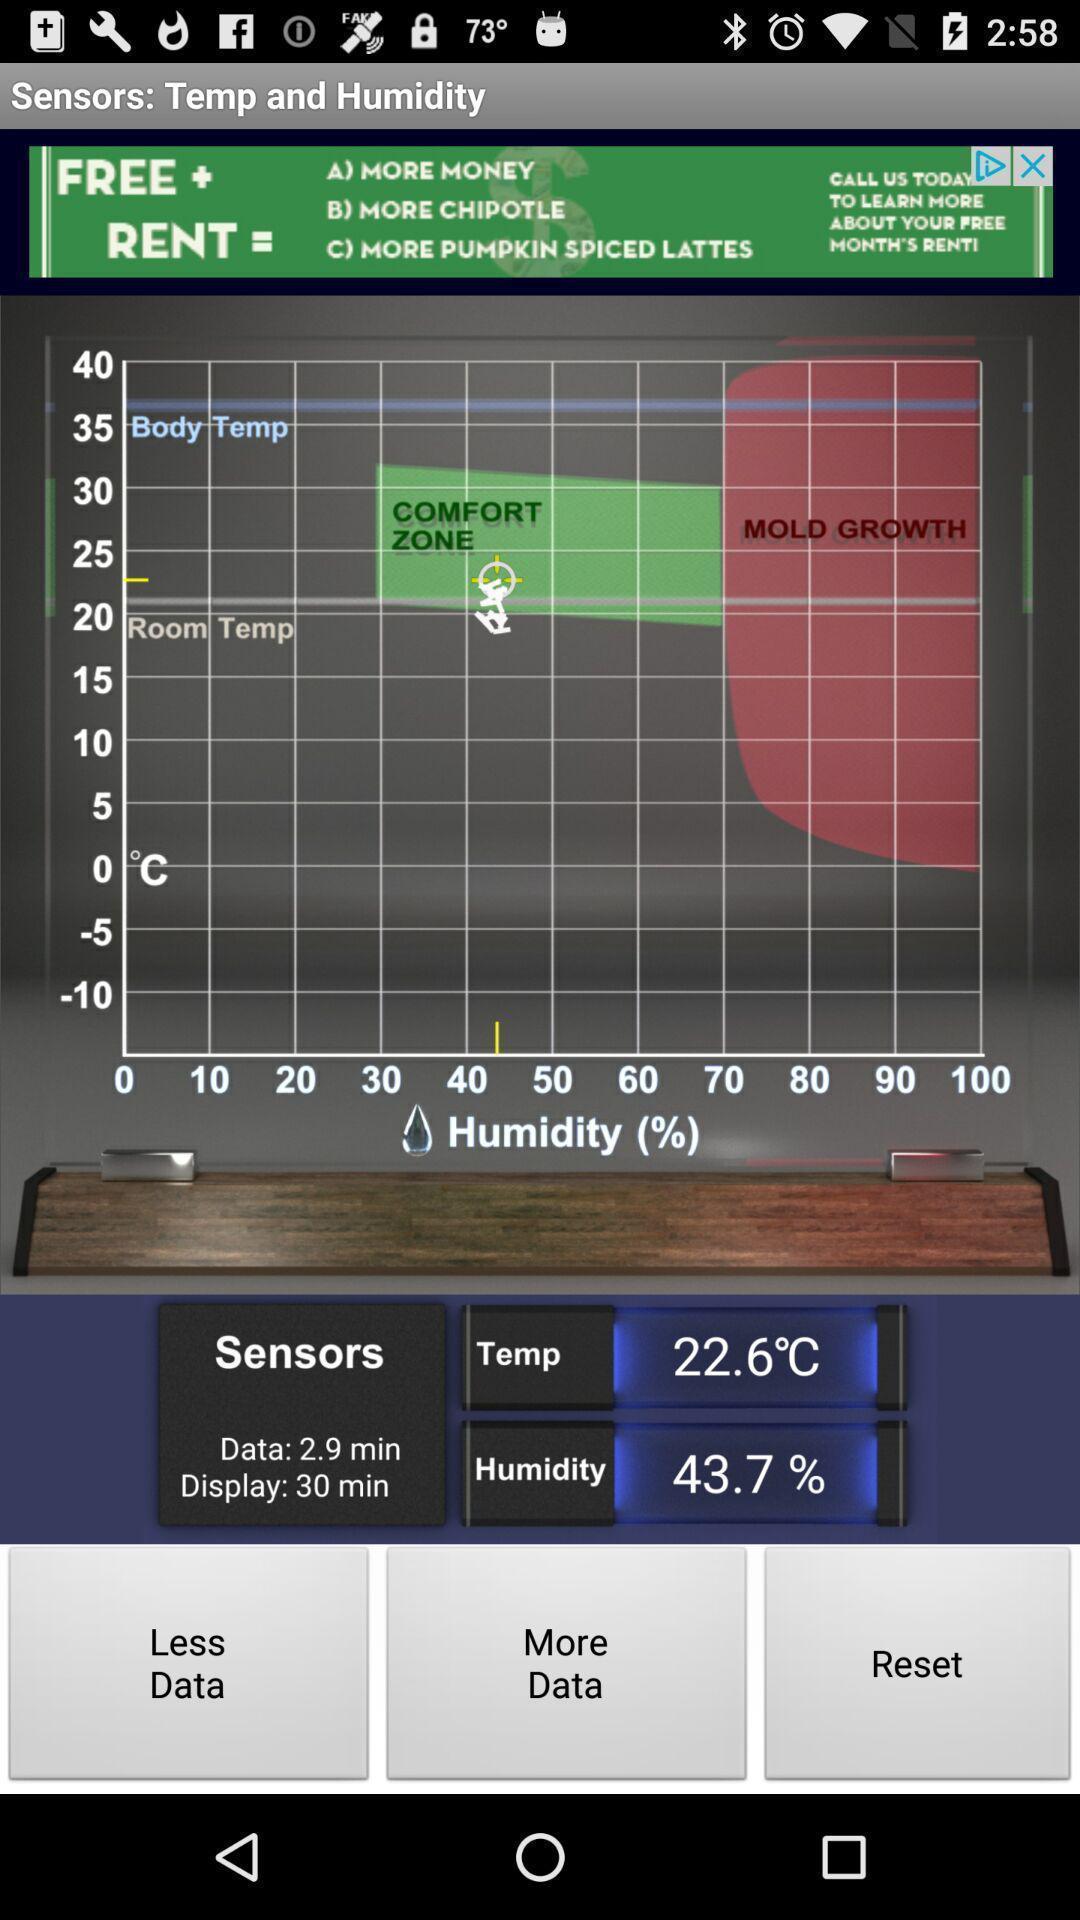What is the overall content of this screenshot? Social app for showing temperature. 